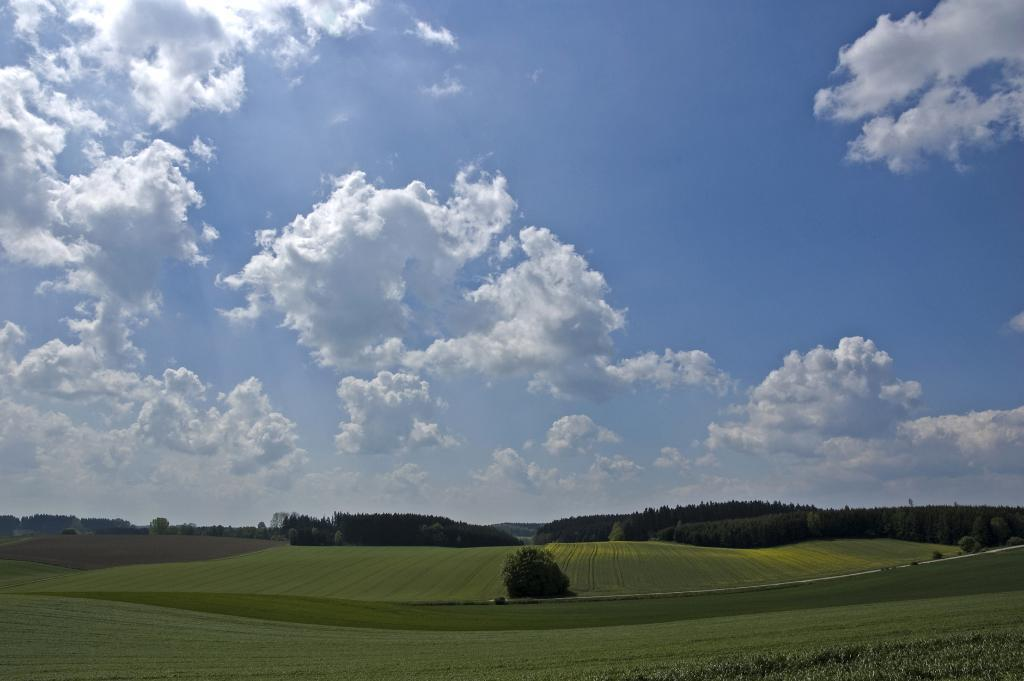What type of ground surface is visible in the image? There is grass on the ground in the image. What other vegetation can be seen on the grass? There are plants visible on the grass. What can be seen in the distance in the image? There are trees in the background of the image. How would you describe the sky in the image? The sky is blue and cloudy in the image. What type of error can be seen in the image? There is no error present in the image; it is a natural scene with grass, plants, trees, and a blue, cloudy sky. 